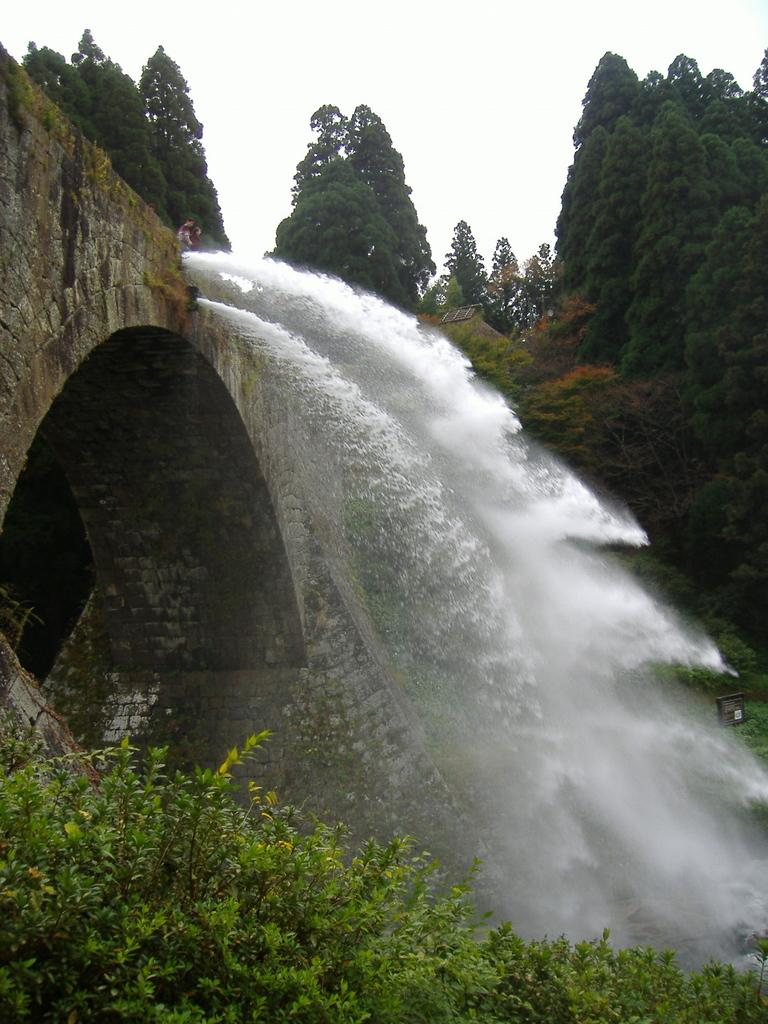What is happening with the pipes in the image? Water is flowing from flowing from pipes in the image. What structure can be seen in the image? There is a bridge in the image. What type of vegetation is present in the image? There are plants and trees in the image. What can be seen in the background of the image? The sky is visible in the background of the image. What type of sound can be heard coming from the rod in the image? There is no rod present in the image, so it is not possible to determine what sound might be heard. 